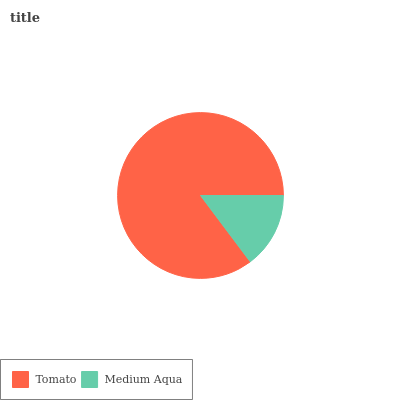Is Medium Aqua the minimum?
Answer yes or no. Yes. Is Tomato the maximum?
Answer yes or no. Yes. Is Medium Aqua the maximum?
Answer yes or no. No. Is Tomato greater than Medium Aqua?
Answer yes or no. Yes. Is Medium Aqua less than Tomato?
Answer yes or no. Yes. Is Medium Aqua greater than Tomato?
Answer yes or no. No. Is Tomato less than Medium Aqua?
Answer yes or no. No. Is Tomato the high median?
Answer yes or no. Yes. Is Medium Aqua the low median?
Answer yes or no. Yes. Is Medium Aqua the high median?
Answer yes or no. No. Is Tomato the low median?
Answer yes or no. No. 